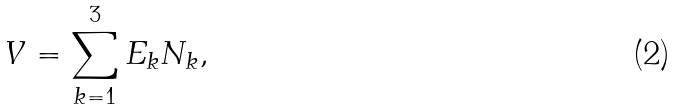<formula> <loc_0><loc_0><loc_500><loc_500>V = \sum _ { k = 1 } ^ { 3 } E _ { k } N _ { k } ,</formula> 